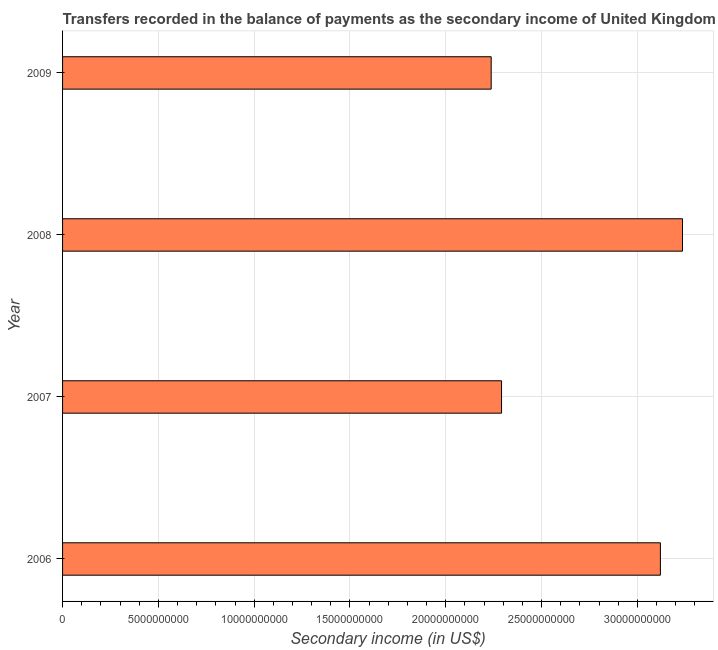Does the graph contain any zero values?
Your answer should be very brief. No. Does the graph contain grids?
Offer a terse response. Yes. What is the title of the graph?
Your response must be concise. Transfers recorded in the balance of payments as the secondary income of United Kingdom. What is the label or title of the X-axis?
Offer a very short reply. Secondary income (in US$). What is the amount of secondary income in 2008?
Your answer should be compact. 3.24e+1. Across all years, what is the maximum amount of secondary income?
Ensure brevity in your answer.  3.24e+1. Across all years, what is the minimum amount of secondary income?
Offer a terse response. 2.24e+1. In which year was the amount of secondary income minimum?
Offer a very short reply. 2009. What is the sum of the amount of secondary income?
Offer a terse response. 1.09e+11. What is the difference between the amount of secondary income in 2007 and 2008?
Give a very brief answer. -9.44e+09. What is the average amount of secondary income per year?
Offer a very short reply. 2.72e+1. What is the median amount of secondary income?
Give a very brief answer. 2.71e+1. Do a majority of the years between 2008 and 2006 (inclusive) have amount of secondary income greater than 22000000000 US$?
Your answer should be compact. Yes. What is the ratio of the amount of secondary income in 2006 to that in 2009?
Keep it short and to the point. 1.4. Is the amount of secondary income in 2008 less than that in 2009?
Offer a terse response. No. What is the difference between the highest and the second highest amount of secondary income?
Your answer should be compact. 1.15e+09. Is the sum of the amount of secondary income in 2007 and 2008 greater than the maximum amount of secondary income across all years?
Provide a short and direct response. Yes. What is the difference between the highest and the lowest amount of secondary income?
Offer a terse response. 9.98e+09. What is the Secondary income (in US$) of 2006?
Offer a terse response. 3.12e+1. What is the Secondary income (in US$) of 2007?
Offer a very short reply. 2.29e+1. What is the Secondary income (in US$) in 2008?
Provide a short and direct response. 3.24e+1. What is the Secondary income (in US$) of 2009?
Give a very brief answer. 2.24e+1. What is the difference between the Secondary income (in US$) in 2006 and 2007?
Make the answer very short. 8.29e+09. What is the difference between the Secondary income (in US$) in 2006 and 2008?
Provide a succinct answer. -1.15e+09. What is the difference between the Secondary income (in US$) in 2006 and 2009?
Give a very brief answer. 8.83e+09. What is the difference between the Secondary income (in US$) in 2007 and 2008?
Offer a very short reply. -9.44e+09. What is the difference between the Secondary income (in US$) in 2007 and 2009?
Offer a terse response. 5.41e+08. What is the difference between the Secondary income (in US$) in 2008 and 2009?
Make the answer very short. 9.98e+09. What is the ratio of the Secondary income (in US$) in 2006 to that in 2007?
Make the answer very short. 1.36. What is the ratio of the Secondary income (in US$) in 2006 to that in 2009?
Offer a terse response. 1.4. What is the ratio of the Secondary income (in US$) in 2007 to that in 2008?
Provide a short and direct response. 0.71. What is the ratio of the Secondary income (in US$) in 2007 to that in 2009?
Ensure brevity in your answer.  1.02. What is the ratio of the Secondary income (in US$) in 2008 to that in 2009?
Your answer should be compact. 1.45. 